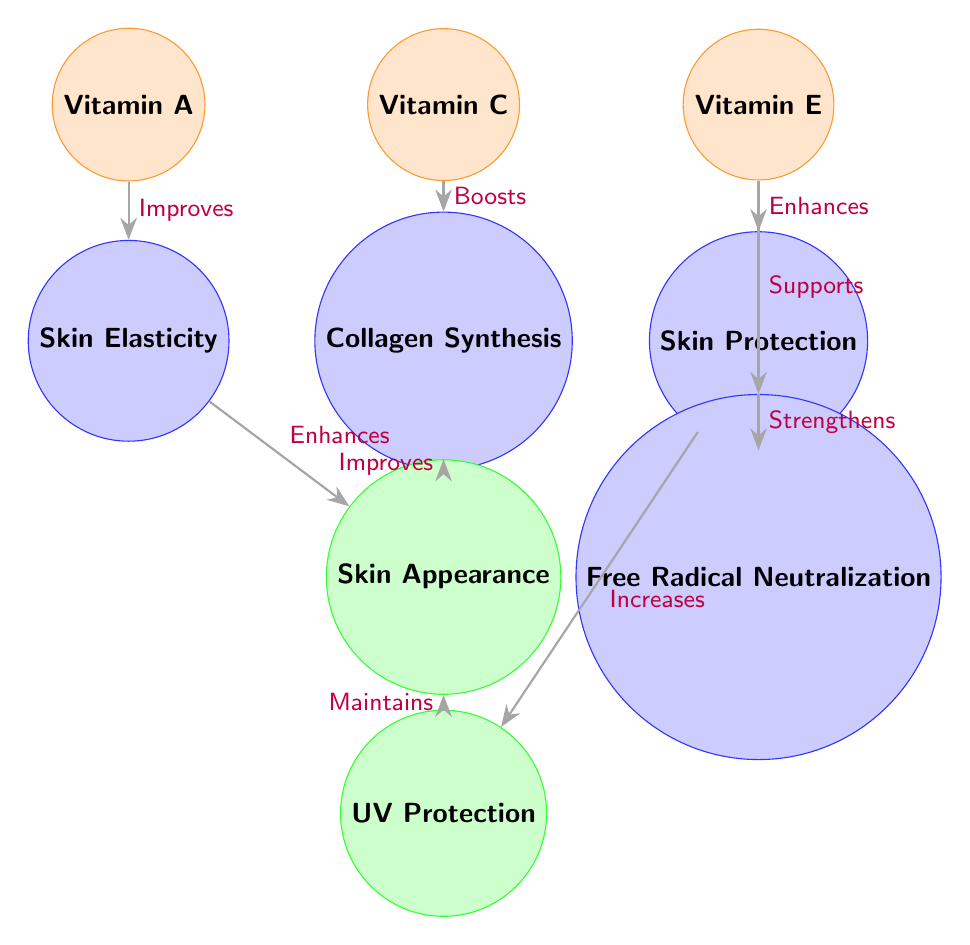What vitamin is associated with skin elasticity? The diagram shows that Vitamin A is linked to the process of Skin Elasticity by an arrow labeled "Improves". Hence, Vitamin A is the vitamin associated with skin elasticity.
Answer: Vitamin A How many vitamins are illustrated in the diagram? The diagram displays three vitamins: Vitamin A, Vitamin C, and Vitamin E. Counting these, we find a total of three vitamins in the diagram.
Answer: 3 What process does Vitamin C boost? According to the diagram, Vitamin C directly affects the Collagen Synthesis process, as indicated by the arrow labeled "Boosts" that connects Vitamin C to Collagen Synthesis.
Answer: Collagen Synthesis Which effect is enhanced by Skin Elasticity? The Skin Elasticity process shows an arrow leading to Skin Appearance, labeled "Enhances." This indicates that the effect of Skin Appearance is enhanced by Skin Elasticity.
Answer: Skin Appearance What is the final effect that maintains Skin Appearance? The diagram indicates that UV Protection, as an effect, has an arrow leading to Skin Appearance with the label "Maintains." Thus, UV Protection is the final effect that maintains Skin Appearance.
Answer: UV Protection How many edges are involved in the connection between Vitamin E and the effects? The diagram shows two edges connected to Vitamin E: one leading to Skin Protection and another leading to Free Radical Neutralization. Therefore, there are two edges involved in the connections.
Answer: 2 What process is supported by Vitamin E? The diagram shows an arrow from Vitamin E to Free Radical Neutralization labeled "Supports," which indicates that Vitamin E supports this process.
Answer: Free Radical Neutralization Which vitamin is responsible for enhancing Skin Protection? The diagram indicates that Vitamin E enhances Skin Protection, as shown by the arrow labeled "Enhances" connecting Vitamin E to Skin Protection.
Answer: Vitamin E 